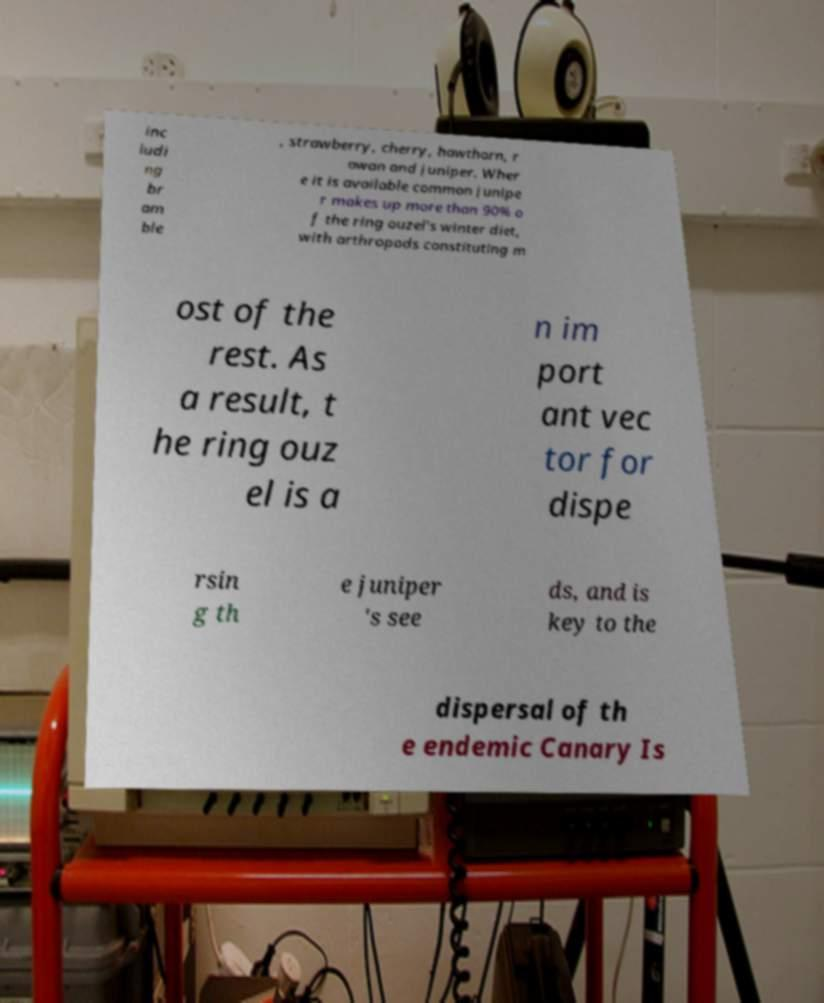Can you accurately transcribe the text from the provided image for me? inc ludi ng br am ble , strawberry, cherry, hawthorn, r owan and juniper. Wher e it is available common junipe r makes up more than 90% o f the ring ouzel's winter diet, with arthropods constituting m ost of the rest. As a result, t he ring ouz el is a n im port ant vec tor for dispe rsin g th e juniper 's see ds, and is key to the dispersal of th e endemic Canary Is 